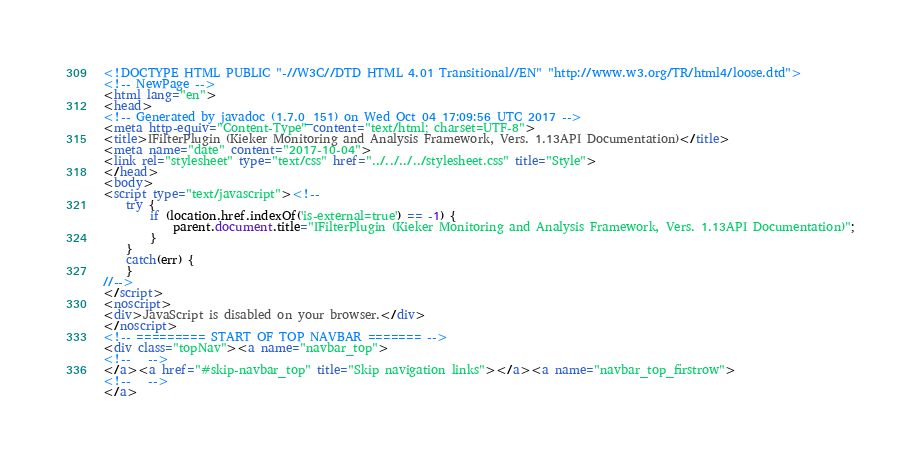Convert code to text. <code><loc_0><loc_0><loc_500><loc_500><_HTML_><!DOCTYPE HTML PUBLIC "-//W3C//DTD HTML 4.01 Transitional//EN" "http://www.w3.org/TR/html4/loose.dtd">
<!-- NewPage -->
<html lang="en">
<head>
<!-- Generated by javadoc (1.7.0_151) on Wed Oct 04 17:09:56 UTC 2017 -->
<meta http-equiv="Content-Type" content="text/html; charset=UTF-8">
<title>IFilterPlugin (Kieker Monitoring and Analysis Framework, Vers. 1.13API Documentation)</title>
<meta name="date" content="2017-10-04">
<link rel="stylesheet" type="text/css" href="../../../../stylesheet.css" title="Style">
</head>
<body>
<script type="text/javascript"><!--
    try {
        if (location.href.indexOf('is-external=true') == -1) {
            parent.document.title="IFilterPlugin (Kieker Monitoring and Analysis Framework, Vers. 1.13API Documentation)";
        }
    }
    catch(err) {
    }
//-->
</script>
<noscript>
<div>JavaScript is disabled on your browser.</div>
</noscript>
<!-- ========= START OF TOP NAVBAR ======= -->
<div class="topNav"><a name="navbar_top">
<!--   -->
</a><a href="#skip-navbar_top" title="Skip navigation links"></a><a name="navbar_top_firstrow">
<!--   -->
</a></code> 